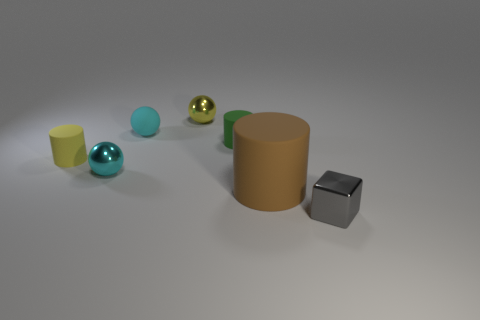Add 1 large blue rubber objects. How many objects exist? 8 Subtract all tiny green matte cylinders. How many cylinders are left? 2 Subtract all yellow cubes. How many cyan spheres are left? 2 Subtract all green cylinders. How many cylinders are left? 2 Subtract 2 cylinders. How many cylinders are left? 1 Subtract 1 yellow balls. How many objects are left? 6 Subtract all balls. How many objects are left? 4 Subtract all purple cubes. Subtract all blue spheres. How many cubes are left? 1 Subtract all green matte cylinders. Subtract all shiny blocks. How many objects are left? 5 Add 5 metallic spheres. How many metallic spheres are left? 7 